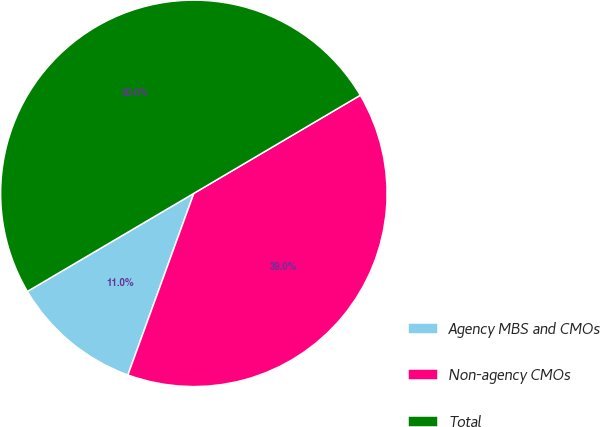<chart> <loc_0><loc_0><loc_500><loc_500><pie_chart><fcel>Agency MBS and CMOs<fcel>Non-agency CMOs<fcel>Total<nl><fcel>10.98%<fcel>39.02%<fcel>50.0%<nl></chart> 